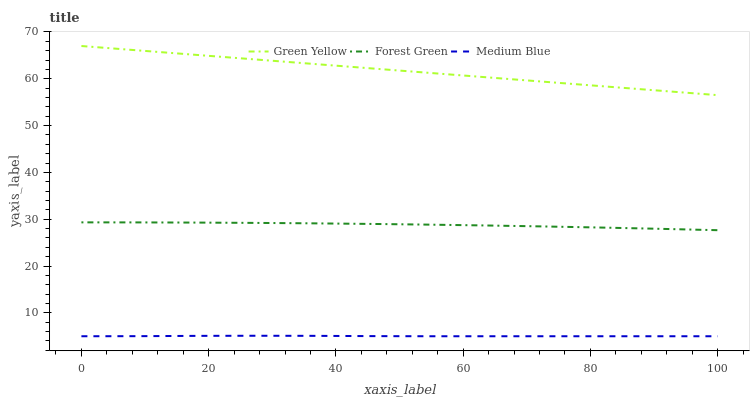Does Medium Blue have the minimum area under the curve?
Answer yes or no. Yes. Does Green Yellow have the maximum area under the curve?
Answer yes or no. Yes. Does Green Yellow have the minimum area under the curve?
Answer yes or no. No. Does Medium Blue have the maximum area under the curve?
Answer yes or no. No. Is Green Yellow the smoothest?
Answer yes or no. Yes. Is Forest Green the roughest?
Answer yes or no. Yes. Is Medium Blue the smoothest?
Answer yes or no. No. Is Medium Blue the roughest?
Answer yes or no. No. Does Green Yellow have the lowest value?
Answer yes or no. No. Does Green Yellow have the highest value?
Answer yes or no. Yes. Does Medium Blue have the highest value?
Answer yes or no. No. Is Medium Blue less than Forest Green?
Answer yes or no. Yes. Is Forest Green greater than Medium Blue?
Answer yes or no. Yes. Does Medium Blue intersect Forest Green?
Answer yes or no. No. 